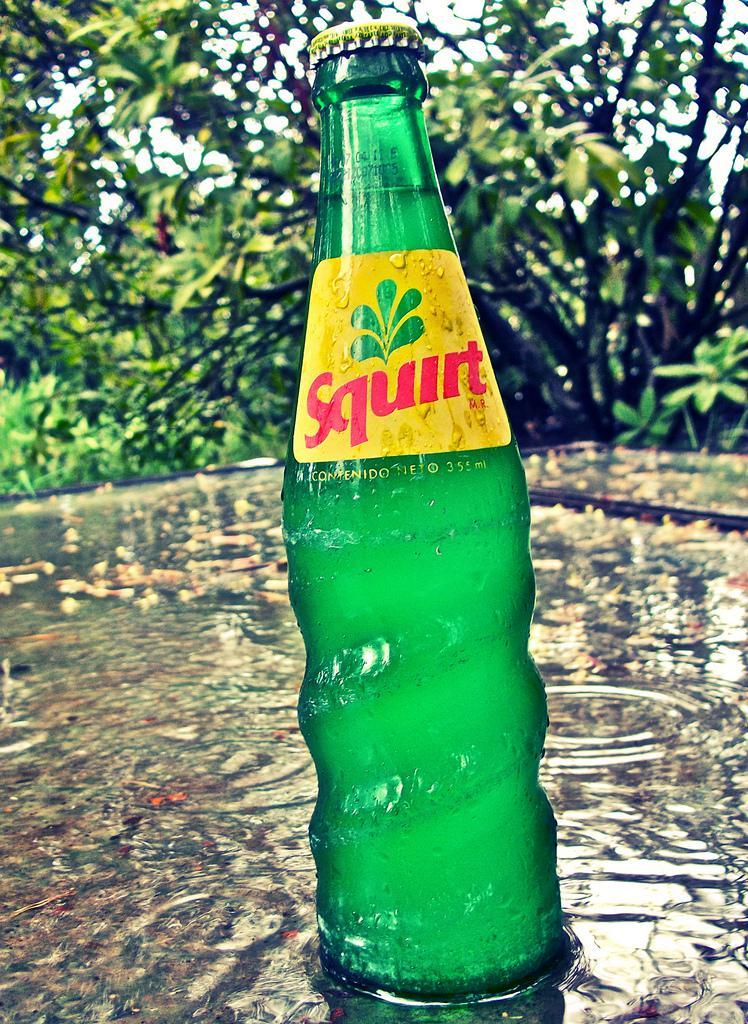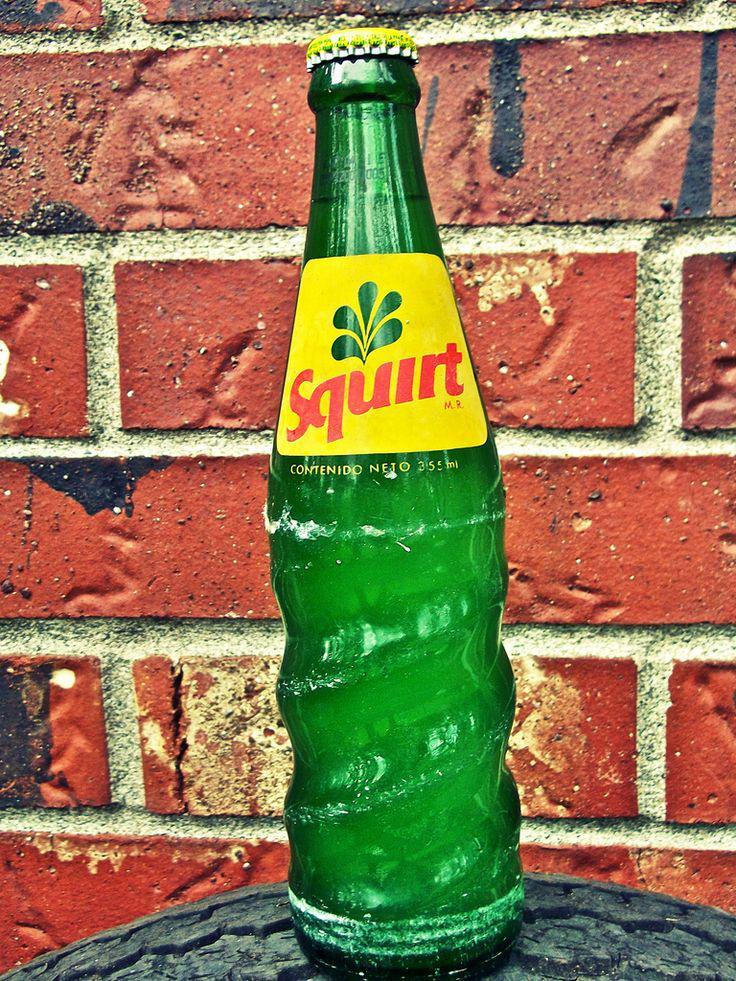The first image is the image on the left, the second image is the image on the right. Assess this claim about the two images: "The left image contains exactly four glass bottles.". Correct or not? Answer yes or no. No. The first image is the image on the left, the second image is the image on the right. Analyze the images presented: Is the assertion "Each image contains one green bottle, and at least one of the bottles pictured has diagonal ribs around its lower half." valid? Answer yes or no. Yes. 